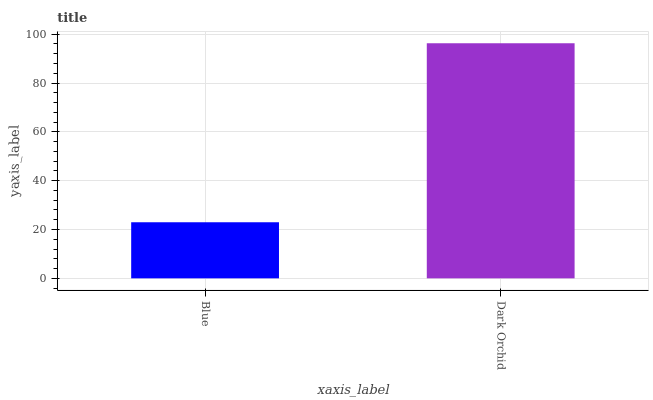Is Blue the minimum?
Answer yes or no. Yes. Is Dark Orchid the maximum?
Answer yes or no. Yes. Is Dark Orchid the minimum?
Answer yes or no. No. Is Dark Orchid greater than Blue?
Answer yes or no. Yes. Is Blue less than Dark Orchid?
Answer yes or no. Yes. Is Blue greater than Dark Orchid?
Answer yes or no. No. Is Dark Orchid less than Blue?
Answer yes or no. No. Is Dark Orchid the high median?
Answer yes or no. Yes. Is Blue the low median?
Answer yes or no. Yes. Is Blue the high median?
Answer yes or no. No. Is Dark Orchid the low median?
Answer yes or no. No. 